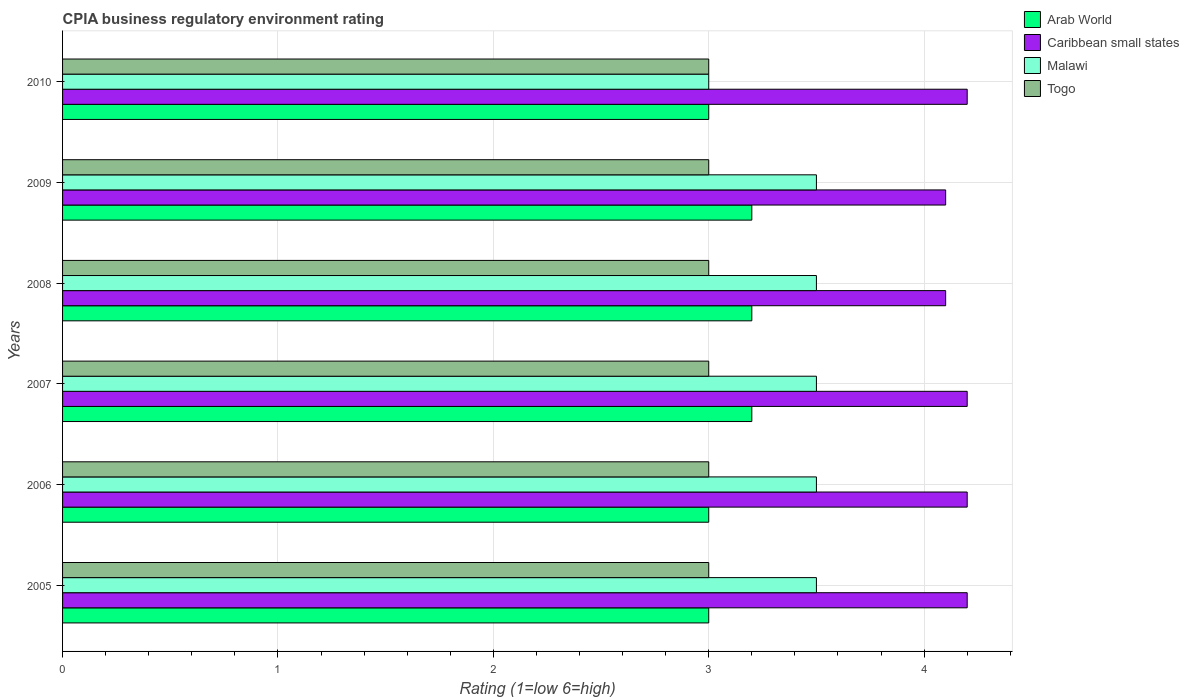How many groups of bars are there?
Ensure brevity in your answer.  6. Are the number of bars per tick equal to the number of legend labels?
Your answer should be compact. Yes. Are the number of bars on each tick of the Y-axis equal?
Give a very brief answer. Yes. How many bars are there on the 6th tick from the top?
Make the answer very short. 4. What is the label of the 4th group of bars from the top?
Give a very brief answer. 2007. In how many cases, is the number of bars for a given year not equal to the number of legend labels?
Keep it short and to the point. 0. Across all years, what is the maximum CPIA rating in Togo?
Offer a very short reply. 3. In which year was the CPIA rating in Caribbean small states maximum?
Make the answer very short. 2005. What is the total CPIA rating in Arab World in the graph?
Make the answer very short. 18.6. What is the difference between the CPIA rating in Togo in 2005 and that in 2006?
Offer a very short reply. 0. What is the average CPIA rating in Togo per year?
Your response must be concise. 3. In the year 2007, what is the difference between the CPIA rating in Malawi and CPIA rating in Caribbean small states?
Ensure brevity in your answer.  -0.7. What is the ratio of the CPIA rating in Caribbean small states in 2005 to that in 2009?
Ensure brevity in your answer.  1.02. Is the CPIA rating in Togo in 2007 less than that in 2009?
Your answer should be very brief. No. Is the difference between the CPIA rating in Malawi in 2005 and 2006 greater than the difference between the CPIA rating in Caribbean small states in 2005 and 2006?
Provide a short and direct response. No. What is the difference between the highest and the lowest CPIA rating in Malawi?
Offer a very short reply. 0.5. In how many years, is the CPIA rating in Malawi greater than the average CPIA rating in Malawi taken over all years?
Keep it short and to the point. 5. What does the 4th bar from the top in 2006 represents?
Keep it short and to the point. Arab World. What does the 1st bar from the bottom in 2005 represents?
Provide a succinct answer. Arab World. Is it the case that in every year, the sum of the CPIA rating in Arab World and CPIA rating in Caribbean small states is greater than the CPIA rating in Togo?
Ensure brevity in your answer.  Yes. Are all the bars in the graph horizontal?
Give a very brief answer. Yes. How many years are there in the graph?
Provide a short and direct response. 6. Does the graph contain any zero values?
Offer a terse response. No. Does the graph contain grids?
Your response must be concise. Yes. How are the legend labels stacked?
Ensure brevity in your answer.  Vertical. What is the title of the graph?
Your answer should be compact. CPIA business regulatory environment rating. What is the label or title of the Y-axis?
Your answer should be very brief. Years. What is the Rating (1=low 6=high) in Arab World in 2005?
Make the answer very short. 3. What is the Rating (1=low 6=high) of Caribbean small states in 2005?
Your response must be concise. 4.2. What is the Rating (1=low 6=high) of Malawi in 2005?
Provide a succinct answer. 3.5. What is the Rating (1=low 6=high) of Togo in 2005?
Your response must be concise. 3. What is the Rating (1=low 6=high) in Arab World in 2006?
Provide a succinct answer. 3. What is the Rating (1=low 6=high) in Caribbean small states in 2006?
Make the answer very short. 4.2. What is the Rating (1=low 6=high) in Malawi in 2006?
Offer a very short reply. 3.5. What is the Rating (1=low 6=high) of Togo in 2006?
Offer a very short reply. 3. What is the Rating (1=low 6=high) in Arab World in 2007?
Keep it short and to the point. 3.2. What is the Rating (1=low 6=high) of Caribbean small states in 2007?
Offer a very short reply. 4.2. What is the Rating (1=low 6=high) of Malawi in 2007?
Provide a succinct answer. 3.5. What is the Rating (1=low 6=high) of Togo in 2007?
Keep it short and to the point. 3. What is the Rating (1=low 6=high) of Caribbean small states in 2008?
Give a very brief answer. 4.1. What is the Rating (1=low 6=high) in Togo in 2008?
Give a very brief answer. 3. What is the Rating (1=low 6=high) in Arab World in 2009?
Your answer should be compact. 3.2. What is the Rating (1=low 6=high) in Caribbean small states in 2009?
Provide a short and direct response. 4.1. What is the Rating (1=low 6=high) of Malawi in 2009?
Your answer should be compact. 3.5. What is the Rating (1=low 6=high) in Togo in 2009?
Provide a succinct answer. 3. What is the Rating (1=low 6=high) of Malawi in 2010?
Offer a terse response. 3. What is the Rating (1=low 6=high) of Togo in 2010?
Offer a terse response. 3. Across all years, what is the maximum Rating (1=low 6=high) in Arab World?
Your answer should be compact. 3.2. Across all years, what is the maximum Rating (1=low 6=high) of Caribbean small states?
Offer a very short reply. 4.2. Across all years, what is the minimum Rating (1=low 6=high) in Arab World?
Ensure brevity in your answer.  3. Across all years, what is the minimum Rating (1=low 6=high) in Togo?
Provide a short and direct response. 3. What is the total Rating (1=low 6=high) in Malawi in the graph?
Provide a succinct answer. 20.5. What is the difference between the Rating (1=low 6=high) of Arab World in 2005 and that in 2006?
Give a very brief answer. 0. What is the difference between the Rating (1=low 6=high) of Malawi in 2005 and that in 2006?
Your response must be concise. 0. What is the difference between the Rating (1=low 6=high) in Togo in 2005 and that in 2006?
Ensure brevity in your answer.  0. What is the difference between the Rating (1=low 6=high) of Arab World in 2005 and that in 2007?
Provide a short and direct response. -0.2. What is the difference between the Rating (1=low 6=high) of Togo in 2005 and that in 2007?
Your answer should be compact. 0. What is the difference between the Rating (1=low 6=high) of Arab World in 2005 and that in 2008?
Keep it short and to the point. -0.2. What is the difference between the Rating (1=low 6=high) in Caribbean small states in 2005 and that in 2008?
Your answer should be compact. 0.1. What is the difference between the Rating (1=low 6=high) in Caribbean small states in 2005 and that in 2009?
Your answer should be compact. 0.1. What is the difference between the Rating (1=low 6=high) in Togo in 2005 and that in 2009?
Your answer should be compact. 0. What is the difference between the Rating (1=low 6=high) in Malawi in 2005 and that in 2010?
Your answer should be very brief. 0.5. What is the difference between the Rating (1=low 6=high) in Togo in 2005 and that in 2010?
Ensure brevity in your answer.  0. What is the difference between the Rating (1=low 6=high) in Arab World in 2006 and that in 2007?
Provide a succinct answer. -0.2. What is the difference between the Rating (1=low 6=high) in Caribbean small states in 2006 and that in 2007?
Provide a short and direct response. 0. What is the difference between the Rating (1=low 6=high) in Malawi in 2006 and that in 2007?
Your answer should be very brief. 0. What is the difference between the Rating (1=low 6=high) in Caribbean small states in 2006 and that in 2008?
Your response must be concise. 0.1. What is the difference between the Rating (1=low 6=high) in Malawi in 2006 and that in 2008?
Ensure brevity in your answer.  0. What is the difference between the Rating (1=low 6=high) in Caribbean small states in 2006 and that in 2009?
Your answer should be compact. 0.1. What is the difference between the Rating (1=low 6=high) of Arab World in 2006 and that in 2010?
Ensure brevity in your answer.  0. What is the difference between the Rating (1=low 6=high) in Malawi in 2006 and that in 2010?
Your answer should be compact. 0.5. What is the difference between the Rating (1=low 6=high) of Caribbean small states in 2007 and that in 2008?
Ensure brevity in your answer.  0.1. What is the difference between the Rating (1=low 6=high) of Malawi in 2007 and that in 2008?
Your answer should be very brief. 0. What is the difference between the Rating (1=low 6=high) of Arab World in 2007 and that in 2010?
Your response must be concise. 0.2. What is the difference between the Rating (1=low 6=high) of Caribbean small states in 2007 and that in 2010?
Provide a short and direct response. 0. What is the difference between the Rating (1=low 6=high) in Malawi in 2007 and that in 2010?
Your answer should be very brief. 0.5. What is the difference between the Rating (1=low 6=high) in Caribbean small states in 2008 and that in 2009?
Give a very brief answer. 0. What is the difference between the Rating (1=low 6=high) of Togo in 2008 and that in 2009?
Your answer should be very brief. 0. What is the difference between the Rating (1=low 6=high) in Caribbean small states in 2008 and that in 2010?
Your response must be concise. -0.1. What is the difference between the Rating (1=low 6=high) of Arab World in 2009 and that in 2010?
Your response must be concise. 0.2. What is the difference between the Rating (1=low 6=high) in Arab World in 2005 and the Rating (1=low 6=high) in Malawi in 2006?
Offer a very short reply. -0.5. What is the difference between the Rating (1=low 6=high) of Caribbean small states in 2005 and the Rating (1=low 6=high) of Togo in 2006?
Offer a very short reply. 1.2. What is the difference between the Rating (1=low 6=high) in Arab World in 2005 and the Rating (1=low 6=high) in Malawi in 2007?
Give a very brief answer. -0.5. What is the difference between the Rating (1=low 6=high) in Arab World in 2005 and the Rating (1=low 6=high) in Togo in 2007?
Give a very brief answer. 0. What is the difference between the Rating (1=low 6=high) in Caribbean small states in 2005 and the Rating (1=low 6=high) in Malawi in 2007?
Keep it short and to the point. 0.7. What is the difference between the Rating (1=low 6=high) in Malawi in 2005 and the Rating (1=low 6=high) in Togo in 2007?
Provide a succinct answer. 0.5. What is the difference between the Rating (1=low 6=high) of Arab World in 2005 and the Rating (1=low 6=high) of Caribbean small states in 2008?
Offer a terse response. -1.1. What is the difference between the Rating (1=low 6=high) in Arab World in 2005 and the Rating (1=low 6=high) in Malawi in 2008?
Make the answer very short. -0.5. What is the difference between the Rating (1=low 6=high) of Caribbean small states in 2005 and the Rating (1=low 6=high) of Togo in 2008?
Make the answer very short. 1.2. What is the difference between the Rating (1=low 6=high) of Arab World in 2005 and the Rating (1=low 6=high) of Caribbean small states in 2009?
Keep it short and to the point. -1.1. What is the difference between the Rating (1=low 6=high) in Arab World in 2005 and the Rating (1=low 6=high) in Malawi in 2009?
Your answer should be very brief. -0.5. What is the difference between the Rating (1=low 6=high) in Arab World in 2005 and the Rating (1=low 6=high) in Togo in 2009?
Your answer should be compact. 0. What is the difference between the Rating (1=low 6=high) in Caribbean small states in 2005 and the Rating (1=low 6=high) in Togo in 2009?
Ensure brevity in your answer.  1.2. What is the difference between the Rating (1=low 6=high) of Malawi in 2005 and the Rating (1=low 6=high) of Togo in 2009?
Make the answer very short. 0.5. What is the difference between the Rating (1=low 6=high) of Arab World in 2005 and the Rating (1=low 6=high) of Malawi in 2010?
Offer a terse response. 0. What is the difference between the Rating (1=low 6=high) of Caribbean small states in 2005 and the Rating (1=low 6=high) of Togo in 2010?
Provide a short and direct response. 1.2. What is the difference between the Rating (1=low 6=high) of Arab World in 2006 and the Rating (1=low 6=high) of Malawi in 2007?
Offer a very short reply. -0.5. What is the difference between the Rating (1=low 6=high) of Arab World in 2006 and the Rating (1=low 6=high) of Togo in 2007?
Provide a succinct answer. 0. What is the difference between the Rating (1=low 6=high) in Caribbean small states in 2006 and the Rating (1=low 6=high) in Togo in 2007?
Provide a short and direct response. 1.2. What is the difference between the Rating (1=low 6=high) in Malawi in 2006 and the Rating (1=low 6=high) in Togo in 2007?
Provide a succinct answer. 0.5. What is the difference between the Rating (1=low 6=high) in Malawi in 2006 and the Rating (1=low 6=high) in Togo in 2008?
Give a very brief answer. 0.5. What is the difference between the Rating (1=low 6=high) in Arab World in 2006 and the Rating (1=low 6=high) in Togo in 2009?
Make the answer very short. 0. What is the difference between the Rating (1=low 6=high) of Caribbean small states in 2006 and the Rating (1=low 6=high) of Malawi in 2009?
Ensure brevity in your answer.  0.7. What is the difference between the Rating (1=low 6=high) in Caribbean small states in 2006 and the Rating (1=low 6=high) in Togo in 2009?
Give a very brief answer. 1.2. What is the difference between the Rating (1=low 6=high) of Malawi in 2006 and the Rating (1=low 6=high) of Togo in 2009?
Give a very brief answer. 0.5. What is the difference between the Rating (1=low 6=high) in Malawi in 2006 and the Rating (1=low 6=high) in Togo in 2010?
Ensure brevity in your answer.  0.5. What is the difference between the Rating (1=low 6=high) in Arab World in 2007 and the Rating (1=low 6=high) in Caribbean small states in 2008?
Keep it short and to the point. -0.9. What is the difference between the Rating (1=low 6=high) in Arab World in 2007 and the Rating (1=low 6=high) in Togo in 2008?
Keep it short and to the point. 0.2. What is the difference between the Rating (1=low 6=high) in Caribbean small states in 2007 and the Rating (1=low 6=high) in Malawi in 2008?
Your answer should be compact. 0.7. What is the difference between the Rating (1=low 6=high) in Caribbean small states in 2007 and the Rating (1=low 6=high) in Togo in 2008?
Ensure brevity in your answer.  1.2. What is the difference between the Rating (1=low 6=high) in Malawi in 2007 and the Rating (1=low 6=high) in Togo in 2008?
Your answer should be compact. 0.5. What is the difference between the Rating (1=low 6=high) of Arab World in 2007 and the Rating (1=low 6=high) of Caribbean small states in 2009?
Keep it short and to the point. -0.9. What is the difference between the Rating (1=low 6=high) in Arab World in 2007 and the Rating (1=low 6=high) in Malawi in 2009?
Your response must be concise. -0.3. What is the difference between the Rating (1=low 6=high) of Arab World in 2007 and the Rating (1=low 6=high) of Togo in 2009?
Give a very brief answer. 0.2. What is the difference between the Rating (1=low 6=high) in Arab World in 2007 and the Rating (1=low 6=high) in Togo in 2010?
Your answer should be compact. 0.2. What is the difference between the Rating (1=low 6=high) of Malawi in 2007 and the Rating (1=low 6=high) of Togo in 2010?
Keep it short and to the point. 0.5. What is the difference between the Rating (1=low 6=high) of Caribbean small states in 2008 and the Rating (1=low 6=high) of Togo in 2009?
Ensure brevity in your answer.  1.1. What is the difference between the Rating (1=low 6=high) in Arab World in 2008 and the Rating (1=low 6=high) in Malawi in 2010?
Your answer should be very brief. 0.2. What is the difference between the Rating (1=low 6=high) of Caribbean small states in 2008 and the Rating (1=low 6=high) of Togo in 2010?
Make the answer very short. 1.1. What is the difference between the Rating (1=low 6=high) of Malawi in 2008 and the Rating (1=low 6=high) of Togo in 2010?
Provide a short and direct response. 0.5. What is the difference between the Rating (1=low 6=high) in Arab World in 2009 and the Rating (1=low 6=high) in Caribbean small states in 2010?
Provide a succinct answer. -1. What is the difference between the Rating (1=low 6=high) of Arab World in 2009 and the Rating (1=low 6=high) of Togo in 2010?
Keep it short and to the point. 0.2. What is the difference between the Rating (1=low 6=high) in Caribbean small states in 2009 and the Rating (1=low 6=high) in Malawi in 2010?
Your response must be concise. 1.1. What is the average Rating (1=low 6=high) of Arab World per year?
Your answer should be compact. 3.1. What is the average Rating (1=low 6=high) of Caribbean small states per year?
Offer a terse response. 4.17. What is the average Rating (1=low 6=high) in Malawi per year?
Give a very brief answer. 3.42. In the year 2005, what is the difference between the Rating (1=low 6=high) of Arab World and Rating (1=low 6=high) of Caribbean small states?
Your answer should be compact. -1.2. In the year 2005, what is the difference between the Rating (1=low 6=high) in Arab World and Rating (1=low 6=high) in Togo?
Your answer should be compact. 0. In the year 2005, what is the difference between the Rating (1=low 6=high) of Caribbean small states and Rating (1=low 6=high) of Togo?
Your answer should be very brief. 1.2. In the year 2005, what is the difference between the Rating (1=low 6=high) in Malawi and Rating (1=low 6=high) in Togo?
Your answer should be compact. 0.5. In the year 2006, what is the difference between the Rating (1=low 6=high) of Arab World and Rating (1=low 6=high) of Malawi?
Your answer should be compact. -0.5. In the year 2006, what is the difference between the Rating (1=low 6=high) of Arab World and Rating (1=low 6=high) of Togo?
Ensure brevity in your answer.  0. In the year 2006, what is the difference between the Rating (1=low 6=high) of Caribbean small states and Rating (1=low 6=high) of Togo?
Offer a terse response. 1.2. In the year 2007, what is the difference between the Rating (1=low 6=high) of Arab World and Rating (1=low 6=high) of Caribbean small states?
Keep it short and to the point. -1. In the year 2007, what is the difference between the Rating (1=low 6=high) in Caribbean small states and Rating (1=low 6=high) in Malawi?
Offer a very short reply. 0.7. In the year 2007, what is the difference between the Rating (1=low 6=high) in Caribbean small states and Rating (1=low 6=high) in Togo?
Make the answer very short. 1.2. In the year 2007, what is the difference between the Rating (1=low 6=high) in Malawi and Rating (1=low 6=high) in Togo?
Make the answer very short. 0.5. In the year 2008, what is the difference between the Rating (1=low 6=high) of Arab World and Rating (1=low 6=high) of Caribbean small states?
Offer a very short reply. -0.9. In the year 2008, what is the difference between the Rating (1=low 6=high) of Arab World and Rating (1=low 6=high) of Togo?
Give a very brief answer. 0.2. In the year 2008, what is the difference between the Rating (1=low 6=high) of Caribbean small states and Rating (1=low 6=high) of Malawi?
Provide a short and direct response. 0.6. In the year 2008, what is the difference between the Rating (1=low 6=high) in Caribbean small states and Rating (1=low 6=high) in Togo?
Offer a very short reply. 1.1. In the year 2009, what is the difference between the Rating (1=low 6=high) of Arab World and Rating (1=low 6=high) of Caribbean small states?
Ensure brevity in your answer.  -0.9. In the year 2009, what is the difference between the Rating (1=low 6=high) in Caribbean small states and Rating (1=low 6=high) in Malawi?
Your answer should be very brief. 0.6. In the year 2009, what is the difference between the Rating (1=low 6=high) of Caribbean small states and Rating (1=low 6=high) of Togo?
Offer a very short reply. 1.1. In the year 2009, what is the difference between the Rating (1=low 6=high) in Malawi and Rating (1=low 6=high) in Togo?
Ensure brevity in your answer.  0.5. In the year 2010, what is the difference between the Rating (1=low 6=high) of Caribbean small states and Rating (1=low 6=high) of Malawi?
Ensure brevity in your answer.  1.2. In the year 2010, what is the difference between the Rating (1=low 6=high) of Caribbean small states and Rating (1=low 6=high) of Togo?
Make the answer very short. 1.2. In the year 2010, what is the difference between the Rating (1=low 6=high) of Malawi and Rating (1=low 6=high) of Togo?
Your answer should be compact. 0. What is the ratio of the Rating (1=low 6=high) in Caribbean small states in 2005 to that in 2007?
Offer a very short reply. 1. What is the ratio of the Rating (1=low 6=high) of Caribbean small states in 2005 to that in 2008?
Provide a short and direct response. 1.02. What is the ratio of the Rating (1=low 6=high) in Malawi in 2005 to that in 2008?
Your response must be concise. 1. What is the ratio of the Rating (1=low 6=high) of Caribbean small states in 2005 to that in 2009?
Offer a terse response. 1.02. What is the ratio of the Rating (1=low 6=high) of Togo in 2005 to that in 2009?
Make the answer very short. 1. What is the ratio of the Rating (1=low 6=high) in Arab World in 2005 to that in 2010?
Offer a terse response. 1. What is the ratio of the Rating (1=low 6=high) in Caribbean small states in 2005 to that in 2010?
Your response must be concise. 1. What is the ratio of the Rating (1=low 6=high) of Togo in 2005 to that in 2010?
Offer a very short reply. 1. What is the ratio of the Rating (1=low 6=high) of Arab World in 2006 to that in 2007?
Your answer should be very brief. 0.94. What is the ratio of the Rating (1=low 6=high) of Togo in 2006 to that in 2007?
Give a very brief answer. 1. What is the ratio of the Rating (1=low 6=high) of Arab World in 2006 to that in 2008?
Your answer should be very brief. 0.94. What is the ratio of the Rating (1=low 6=high) of Caribbean small states in 2006 to that in 2008?
Provide a short and direct response. 1.02. What is the ratio of the Rating (1=low 6=high) of Malawi in 2006 to that in 2008?
Offer a terse response. 1. What is the ratio of the Rating (1=low 6=high) of Caribbean small states in 2006 to that in 2009?
Offer a terse response. 1.02. What is the ratio of the Rating (1=low 6=high) in Malawi in 2006 to that in 2009?
Offer a terse response. 1. What is the ratio of the Rating (1=low 6=high) in Arab World in 2006 to that in 2010?
Keep it short and to the point. 1. What is the ratio of the Rating (1=low 6=high) in Malawi in 2006 to that in 2010?
Ensure brevity in your answer.  1.17. What is the ratio of the Rating (1=low 6=high) of Arab World in 2007 to that in 2008?
Ensure brevity in your answer.  1. What is the ratio of the Rating (1=low 6=high) in Caribbean small states in 2007 to that in 2008?
Give a very brief answer. 1.02. What is the ratio of the Rating (1=low 6=high) in Arab World in 2007 to that in 2009?
Offer a very short reply. 1. What is the ratio of the Rating (1=low 6=high) in Caribbean small states in 2007 to that in 2009?
Make the answer very short. 1.02. What is the ratio of the Rating (1=low 6=high) of Arab World in 2007 to that in 2010?
Your answer should be compact. 1.07. What is the ratio of the Rating (1=low 6=high) of Togo in 2007 to that in 2010?
Provide a succinct answer. 1. What is the ratio of the Rating (1=low 6=high) in Caribbean small states in 2008 to that in 2009?
Make the answer very short. 1. What is the ratio of the Rating (1=low 6=high) of Malawi in 2008 to that in 2009?
Ensure brevity in your answer.  1. What is the ratio of the Rating (1=low 6=high) in Arab World in 2008 to that in 2010?
Keep it short and to the point. 1.07. What is the ratio of the Rating (1=low 6=high) of Caribbean small states in 2008 to that in 2010?
Make the answer very short. 0.98. What is the ratio of the Rating (1=low 6=high) of Togo in 2008 to that in 2010?
Offer a terse response. 1. What is the ratio of the Rating (1=low 6=high) in Arab World in 2009 to that in 2010?
Keep it short and to the point. 1.07. What is the ratio of the Rating (1=low 6=high) of Caribbean small states in 2009 to that in 2010?
Ensure brevity in your answer.  0.98. What is the ratio of the Rating (1=low 6=high) in Togo in 2009 to that in 2010?
Ensure brevity in your answer.  1. What is the difference between the highest and the second highest Rating (1=low 6=high) in Arab World?
Keep it short and to the point. 0. What is the difference between the highest and the lowest Rating (1=low 6=high) of Caribbean small states?
Your answer should be compact. 0.1. What is the difference between the highest and the lowest Rating (1=low 6=high) in Togo?
Ensure brevity in your answer.  0. 